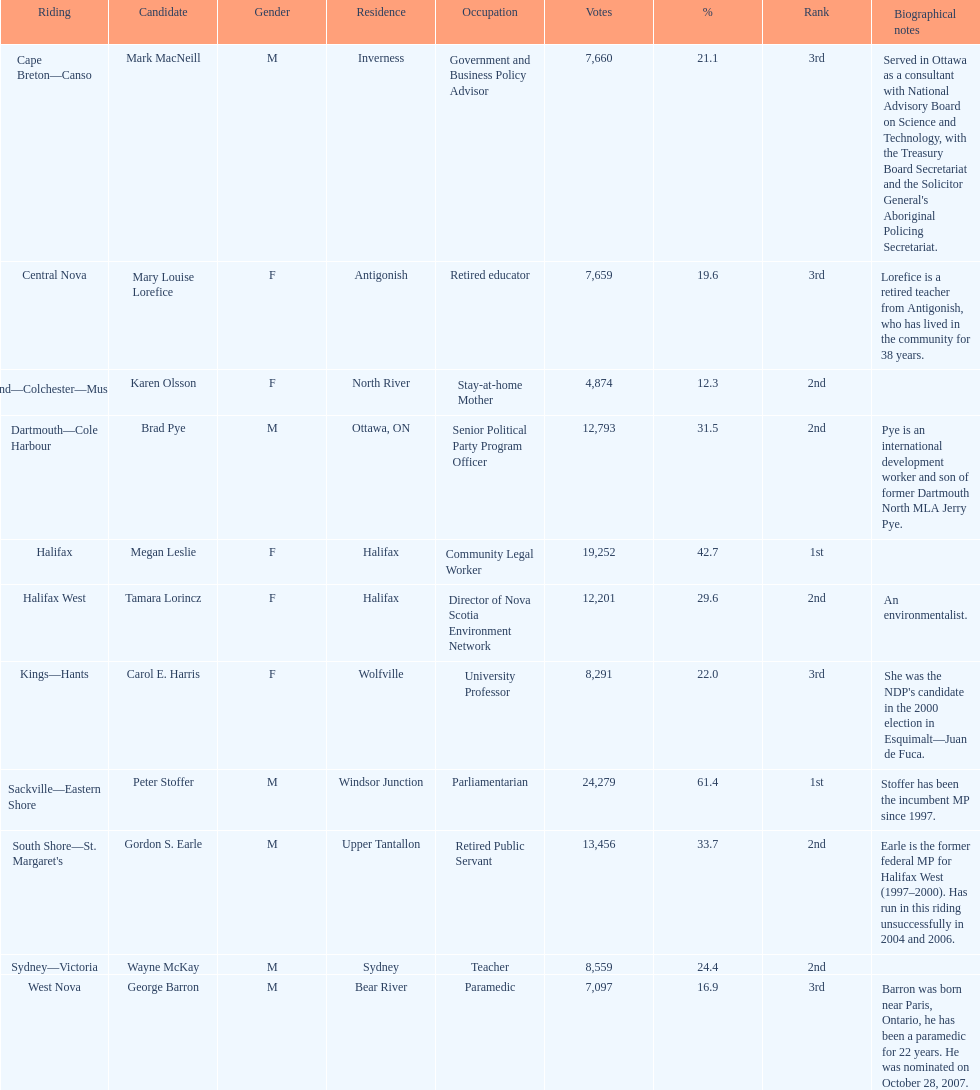Tell me the total number of votes the female candidates got. 52,277. 